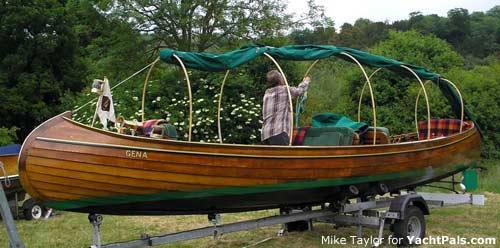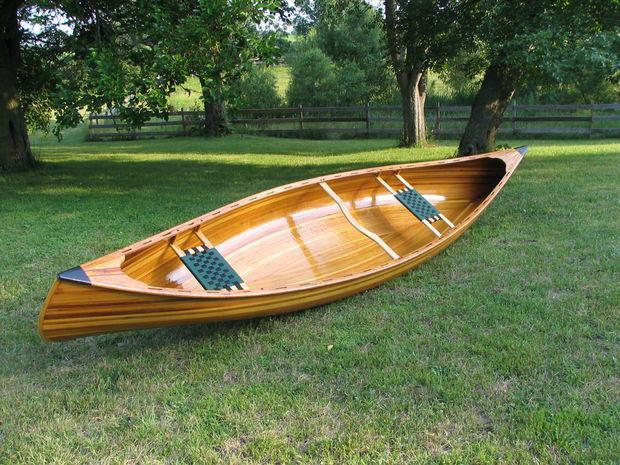The first image is the image on the left, the second image is the image on the right. Considering the images on both sides, is "The left image shows one or more people inside a brown canoe that has a green top visible on it" valid? Answer yes or no. Yes. The first image is the image on the left, the second image is the image on the right. Examine the images to the left and right. Is the description "An image shows exactly one canoe sitting in the water." accurate? Answer yes or no. No. 